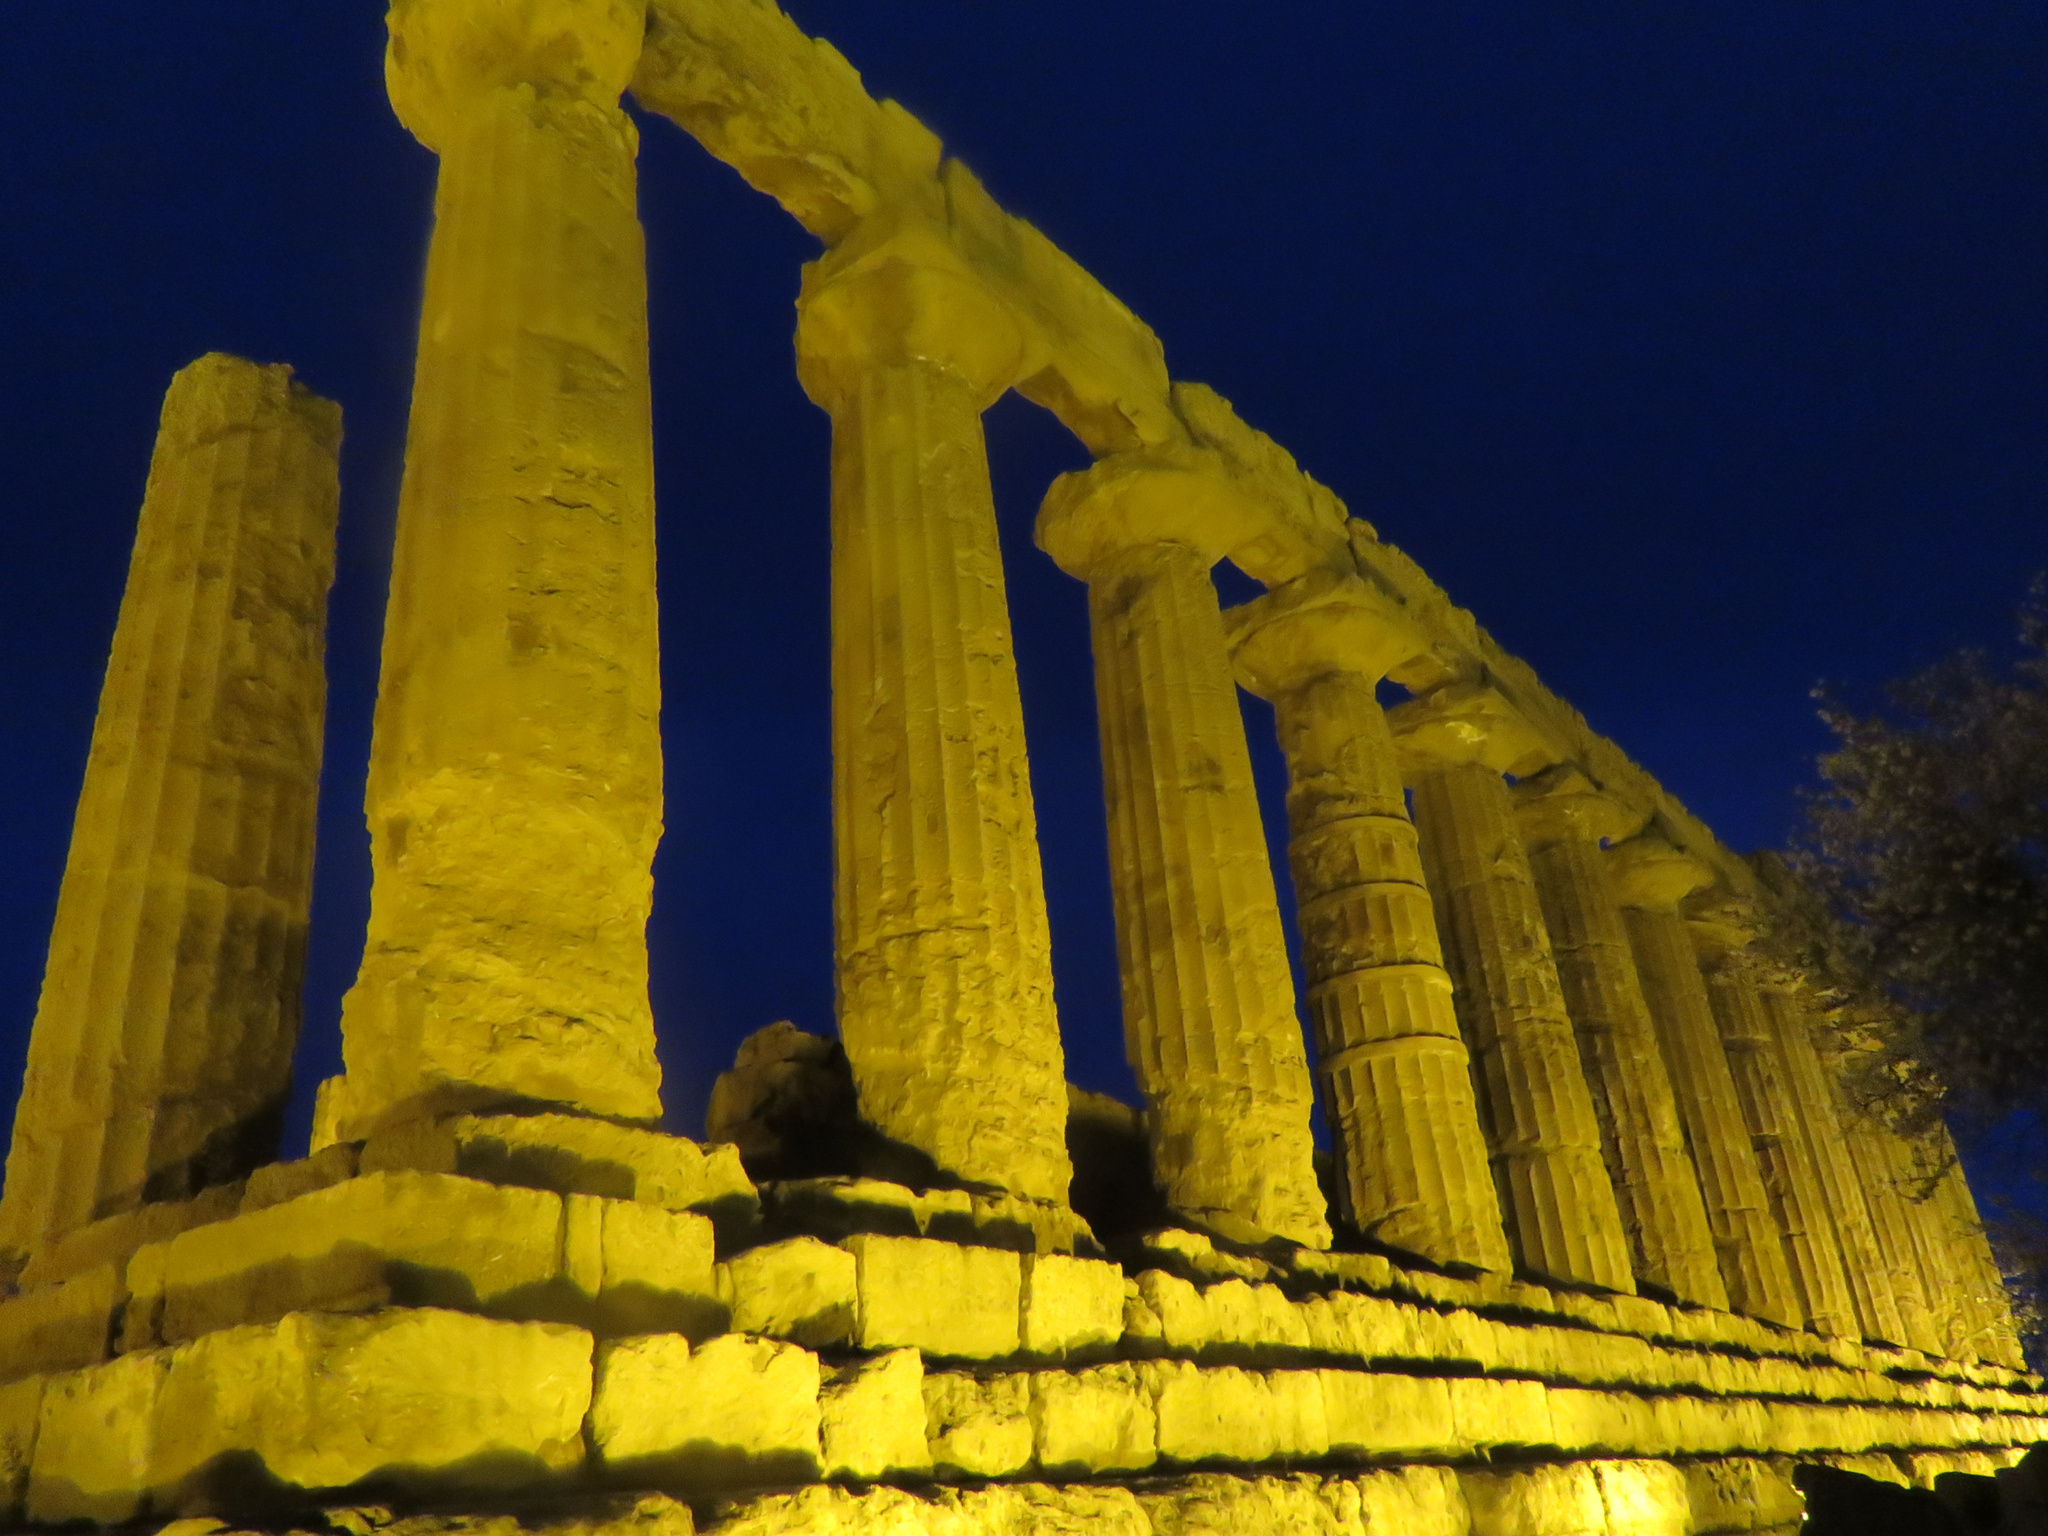Can you describe this image briefly? In this image, there is an outside view. In the foreground, there are some pillars. In the background, there is a sky. 